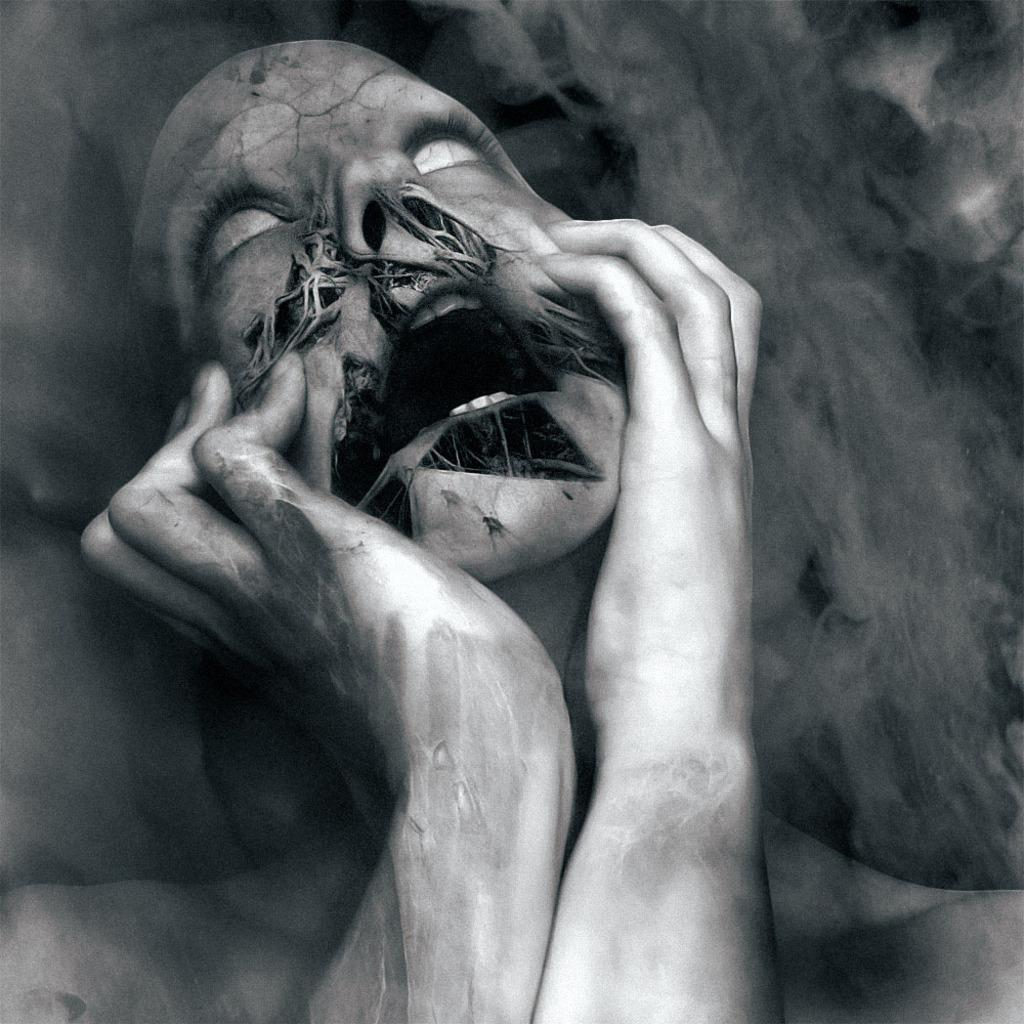What is the main subject of the image? There is a person in the image. What is the person doing in the image? The person is looking up and has both hands on their cheeks with fingers touching. What can be seen in the background of the image? There is smoke in the background of the image, and the background is dark in color. How many circles can be seen on the person's fingers in the image? There are no circles visible on the person's fingers in the image. 